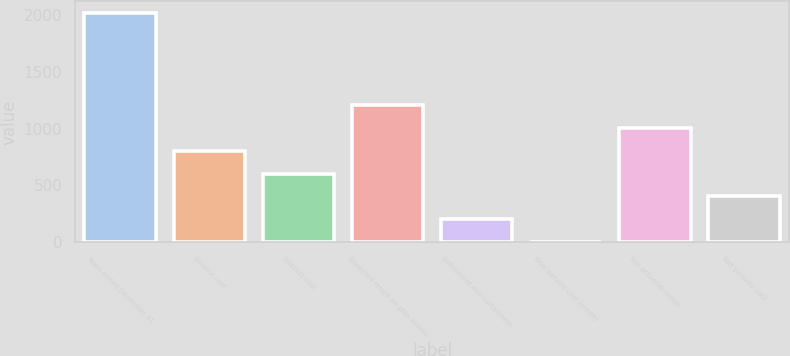<chart> <loc_0><loc_0><loc_500><loc_500><bar_chart><fcel>Years ended December 31<fcel>Service cost<fcel>Interest cost<fcel>Expected return on plan assets<fcel>Settlement and curtailment<fcel>Prior service cost (credit)<fcel>Net actuarial losses<fcel>Net periodic cost<nl><fcel>2017<fcel>806.92<fcel>605.24<fcel>1210.28<fcel>201.88<fcel>0.2<fcel>1008.6<fcel>403.56<nl></chart> 